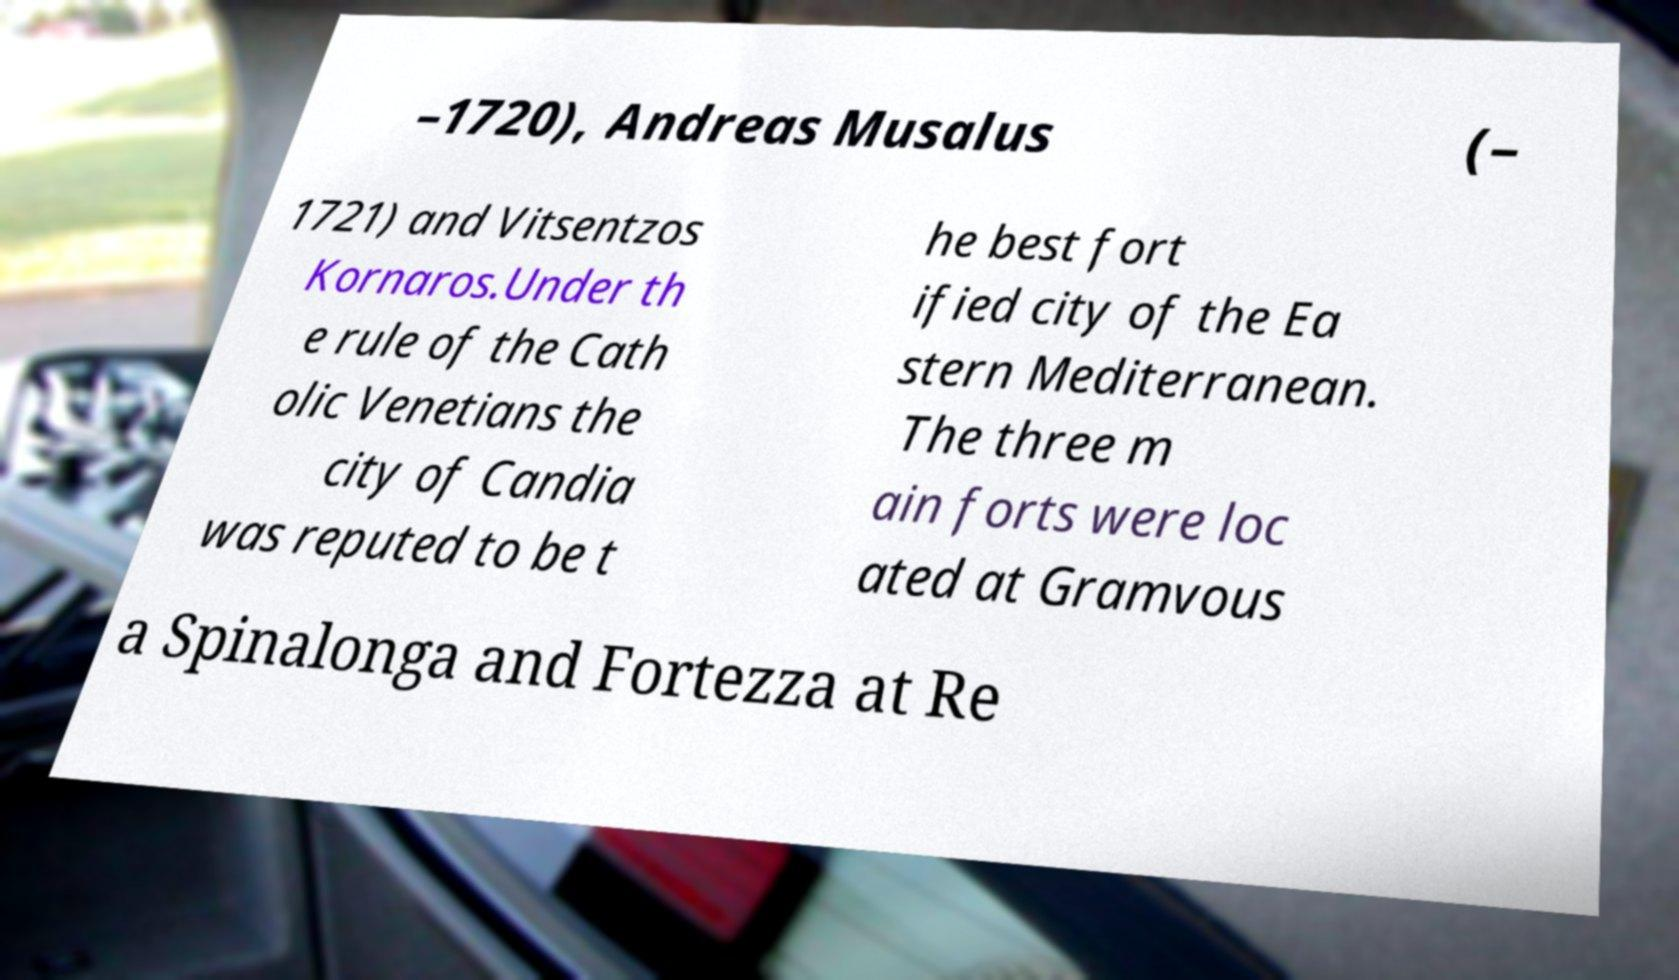Could you extract and type out the text from this image? –1720), Andreas Musalus (– 1721) and Vitsentzos Kornaros.Under th e rule of the Cath olic Venetians the city of Candia was reputed to be t he best fort ified city of the Ea stern Mediterranean. The three m ain forts were loc ated at Gramvous a Spinalonga and Fortezza at Re 